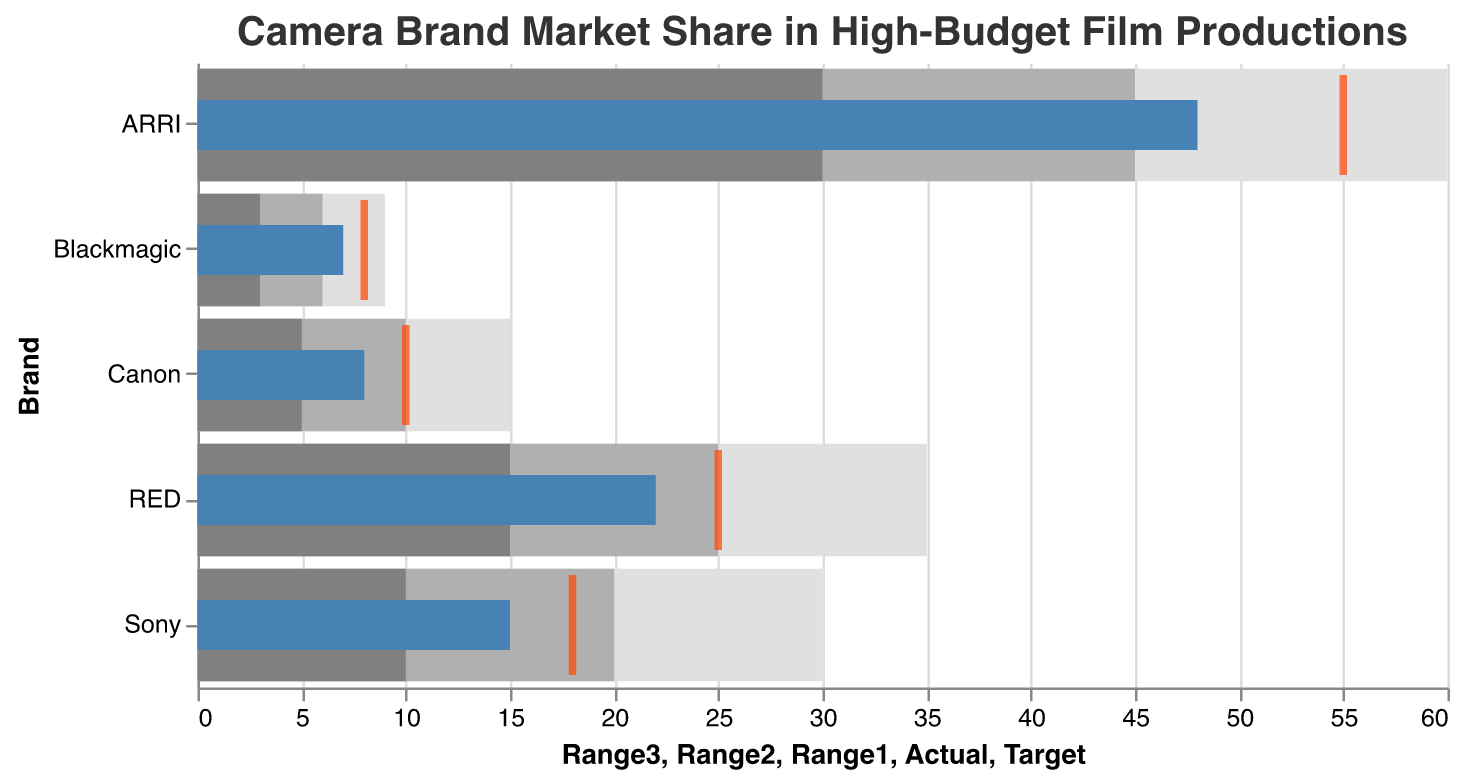What is the title of the chart? The title of the chart is usually displayed at the top and provides a summary of what the chart represents. Here, it is prominently shown as "Camera Brand Market Share in High-Budget Film Productions".
Answer: Camera Brand Market Share in High-Budget Film Productions Which camera brand has the highest actual market share? To determine this, look at the bar with the largest value in the "Actual" column. In this chart, ARRI has the highest value of actual market share with 48.
Answer: ARRI How does the actual market share of RED compare to its target? Observe the lengths of the "Actual" bar (which is 22) and the "Target" tick (which is 25) for RED. The actual market share (22) is smaller than the target market share (25).
Answer: RED's actual market share is 3 less than its target What is the range category that most camera brands fall into? Count the occurrences of brands in each range category according to the light gray, medium gray, and dark gray segments. Most camera brands fall within the 3-30 range segments (Range1: 30, Range2: 45, Range3: 60).
Answer: 3-30 Which camera brand is closest to reaching its target market share? Compare the differences between the "Actual" and "Target" values for each brand. The smallest difference indicates the closest. Blackmagic has an actual of 7 and a target of 8, which is a difference of 1.
Answer: Blackmagic What is the combined actual market share of Canon and Blackmagic? Add the actual market share values of Canon and Blackmagic. Canon has an actual market share of 8, and Blackmagic has 7. The combined market share is 8 + 7, which equals 15.
Answer: 15 How does Sony's actual market share compare to the lower bound of its second range? Sony's actual market share (15) should be compared to the lower bound of Range2, which is 20. The actual market share is lower than this range.
Answer: Sony's actual market share is 5 less than its Range2 lower bound Identify the brands that exceeded their first range category. Evaluate which brands have an "Actual" market share greater than their first range (Range1). ARRI (Actual: 48, Range1: 30), RED (Actual: 22, Range1: 15), Sony (Actual: 15, Range1: 10), Canon (Actual: 8, Range1: 5), and Blackmagic (Actual: 7, Range1: 3) all exceed their first range.
Answer: All brands exceeded their first range What is the difference between ARRI's and RED's target market shares? Subtract RED's target market share from ARRI's. ARRI has a target of 55, and RED has a target of 25. The difference is 55 - 25, which equals 30.
Answer: 30 